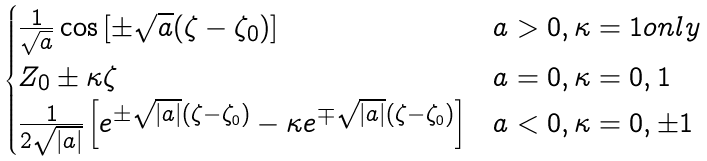Convert formula to latex. <formula><loc_0><loc_0><loc_500><loc_500>\begin{cases} \frac { 1 } { \sqrt { a } } \cos \left [ \pm \sqrt { a } ( \zeta - \zeta _ { 0 } ) \right ] & a > 0 , \kappa = 1 o n l y \\ Z _ { 0 } \pm \kappa \zeta & a = 0 , \kappa = 0 , 1 \\ \frac { 1 } { 2 \sqrt { | a | } } \left [ e ^ { \pm \sqrt { | a | } ( \zeta - \zeta _ { 0 } ) } - \kappa e ^ { \mp \sqrt { | a | } ( \zeta - \zeta _ { 0 } ) } \right ] & a < 0 , \kappa = 0 , \pm 1 \end{cases}</formula> 